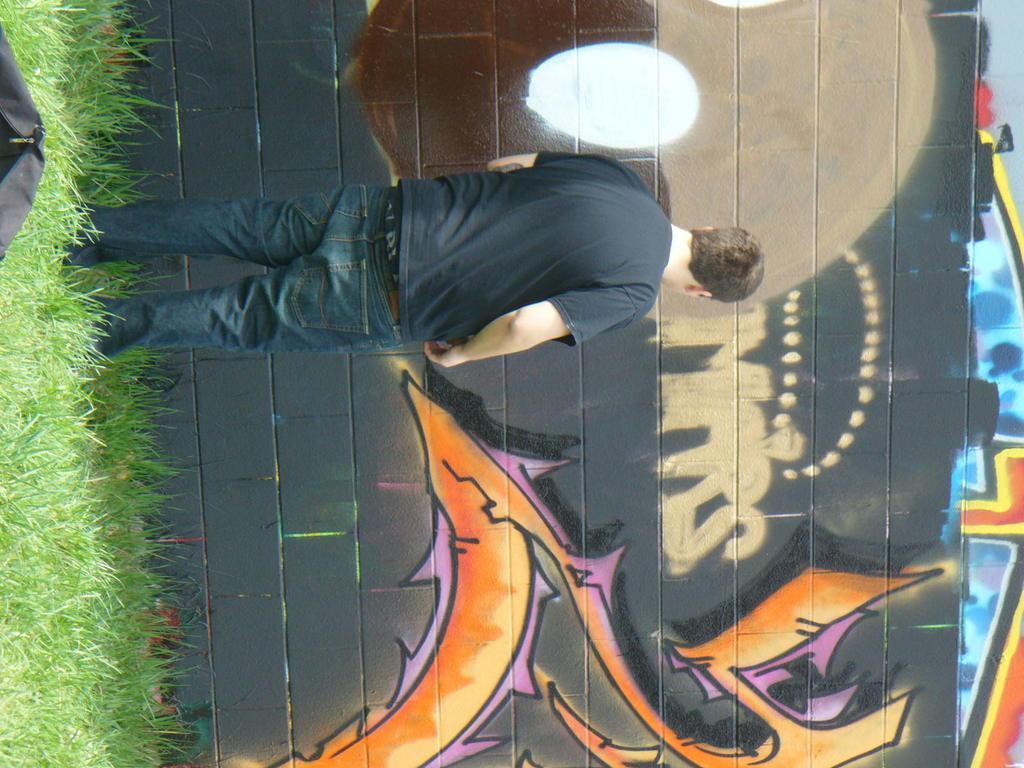How would you summarize this image in a sentence or two? In this picture, we see a man in black T-shirt and a blue jeans is standing. In front of him, we see a wall graffiti and it is in brown, black, white, pink, orange, red, blue and yellow color. On the left side, we see the grass and a bag in black color. 